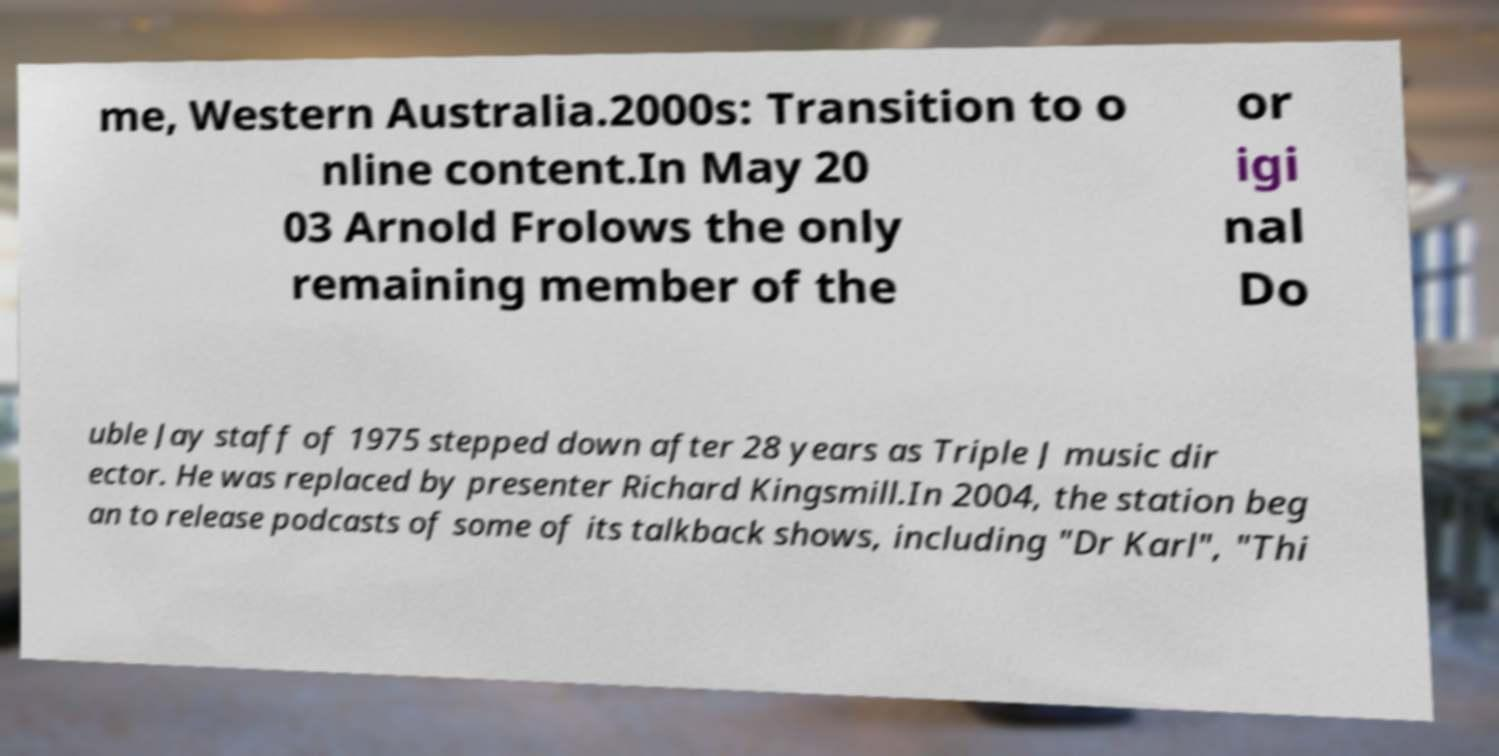I need the written content from this picture converted into text. Can you do that? me, Western Australia.2000s: Transition to o nline content.In May 20 03 Arnold Frolows the only remaining member of the or igi nal Do uble Jay staff of 1975 stepped down after 28 years as Triple J music dir ector. He was replaced by presenter Richard Kingsmill.In 2004, the station beg an to release podcasts of some of its talkback shows, including "Dr Karl", "Thi 